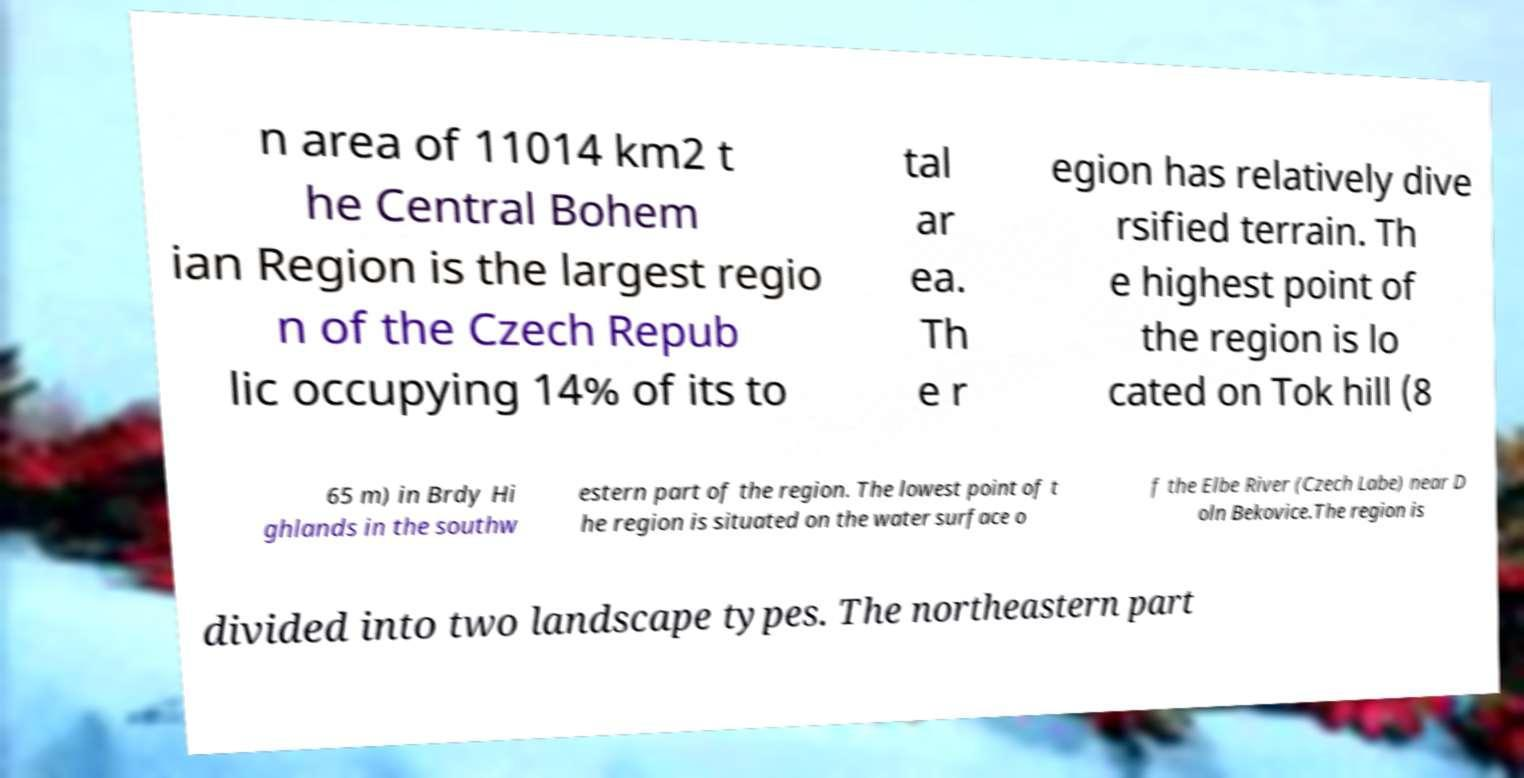What messages or text are displayed in this image? I need them in a readable, typed format. n area of 11014 km2 t he Central Bohem ian Region is the largest regio n of the Czech Repub lic occupying 14% of its to tal ar ea. Th e r egion has relatively dive rsified terrain. Th e highest point of the region is lo cated on Tok hill (8 65 m) in Brdy Hi ghlands in the southw estern part of the region. The lowest point of t he region is situated on the water surface o f the Elbe River (Czech Labe) near D oln Bekovice.The region is divided into two landscape types. The northeastern part 